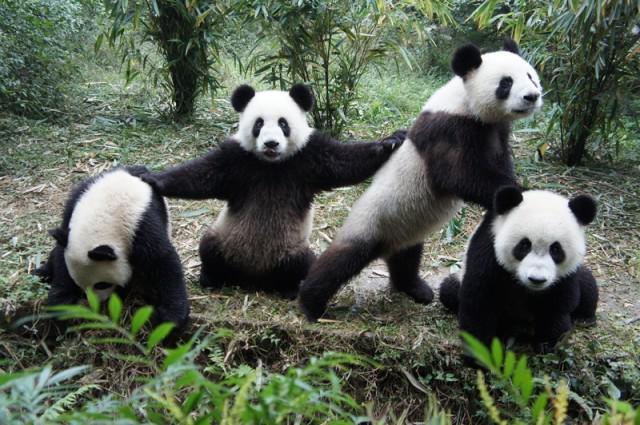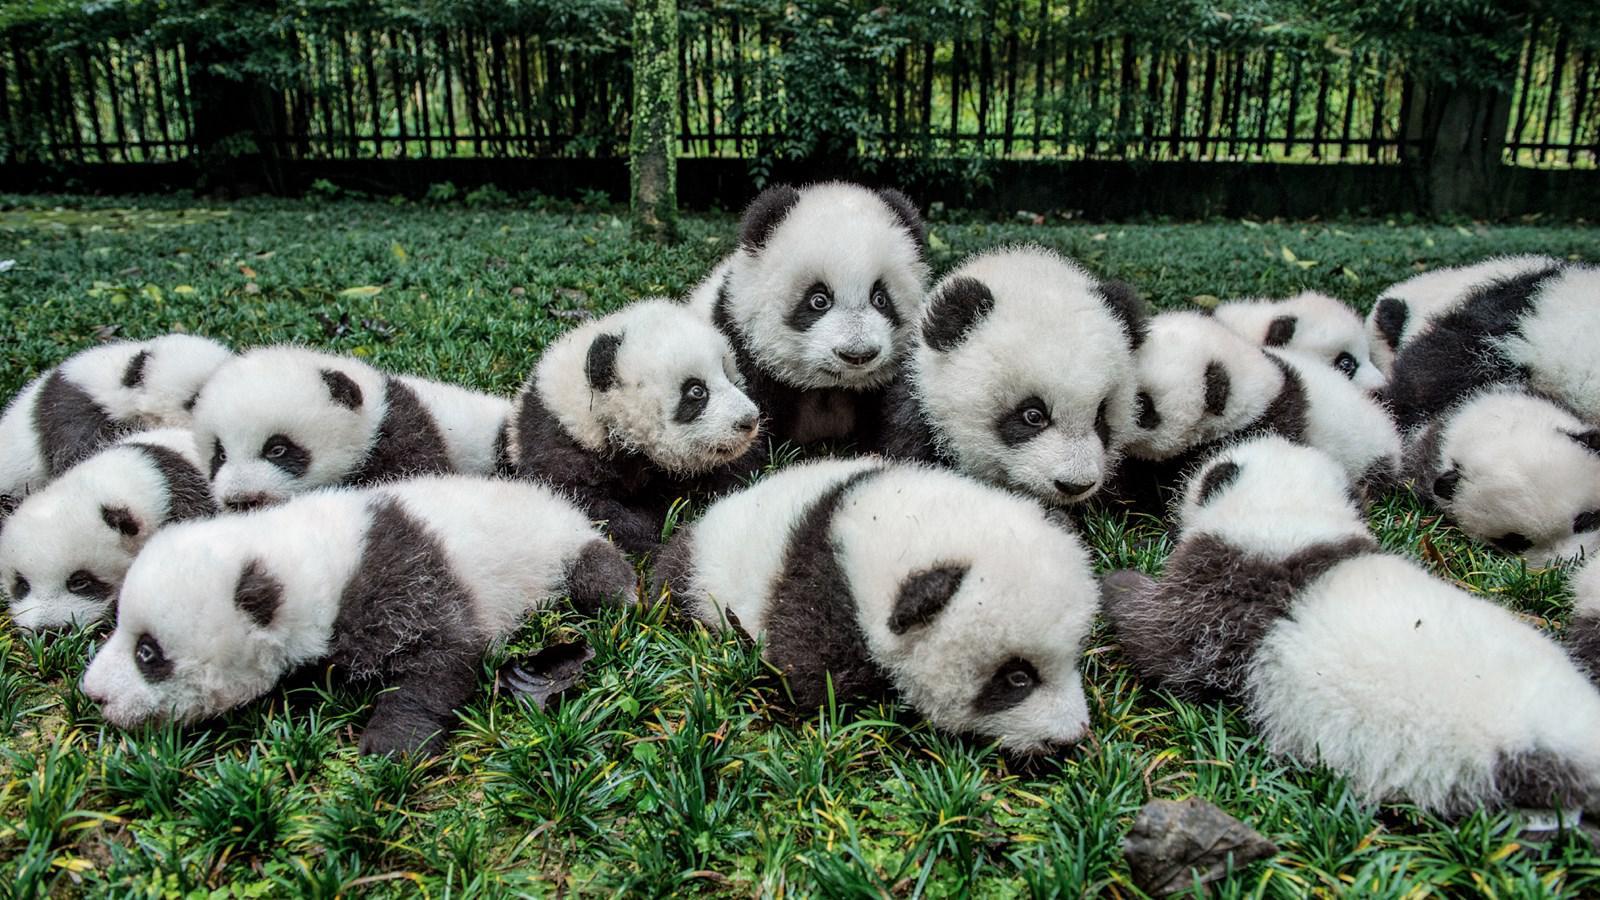The first image is the image on the left, the second image is the image on the right. Considering the images on both sides, is "The image to the left features exactly four pandas." valid? Answer yes or no. Yes. The first image is the image on the left, the second image is the image on the right. Given the left and right images, does the statement "An image with exactly four pandas includes one with its front paws outspread, reaching toward the panda on either side of it." hold true? Answer yes or no. Yes. 